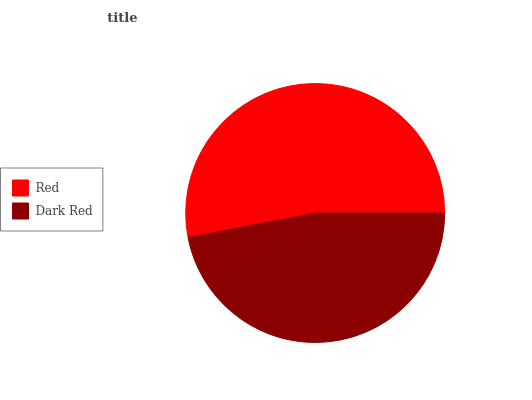Is Dark Red the minimum?
Answer yes or no. Yes. Is Red the maximum?
Answer yes or no. Yes. Is Dark Red the maximum?
Answer yes or no. No. Is Red greater than Dark Red?
Answer yes or no. Yes. Is Dark Red less than Red?
Answer yes or no. Yes. Is Dark Red greater than Red?
Answer yes or no. No. Is Red less than Dark Red?
Answer yes or no. No. Is Red the high median?
Answer yes or no. Yes. Is Dark Red the low median?
Answer yes or no. Yes. Is Dark Red the high median?
Answer yes or no. No. Is Red the low median?
Answer yes or no. No. 